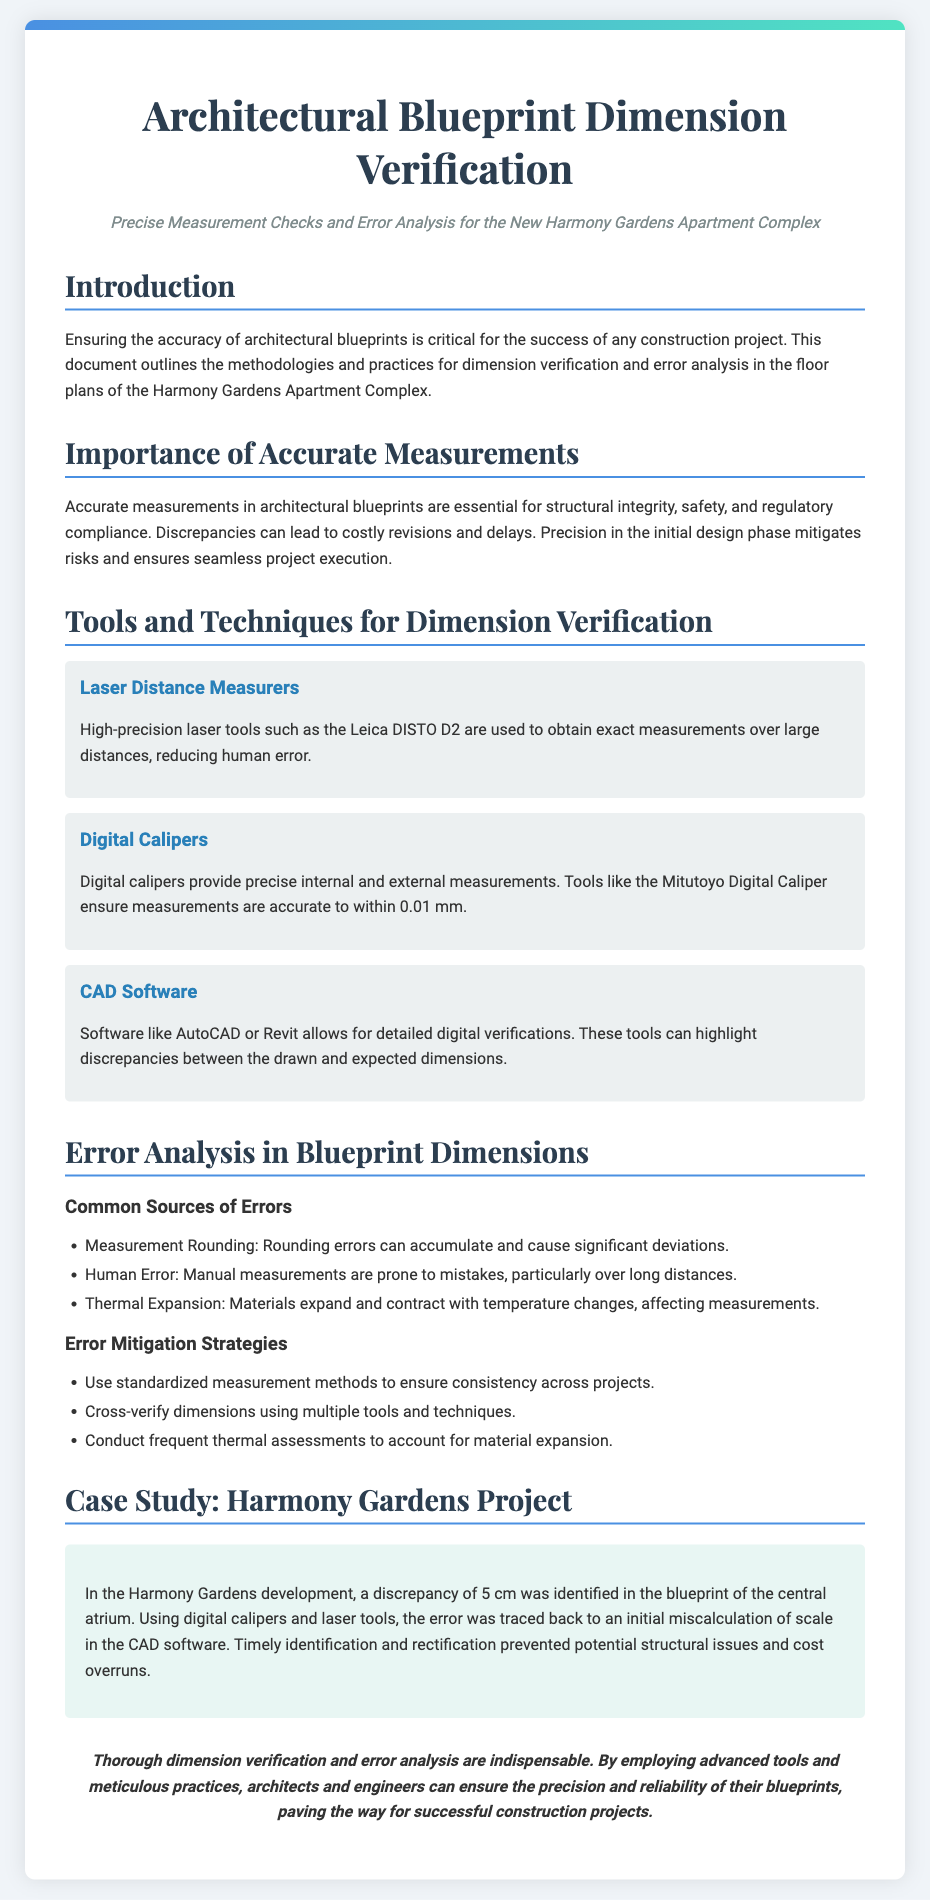What is the title of the document? The title is stated at the top of the document and is "Architectural Blueprint Dimension Verification."
Answer: Architectural Blueprint Dimension Verification What is the subtitle of the document? The subtitle provides additional context and is "Precise Measurement Checks and Error Analysis for the New Harmony Gardens Apartment Complex."
Answer: Precise Measurement Checks and Error Analysis for the New Harmony Gardens Apartment Complex What is one tool used for dimension verification? The document lists multiple tools and one of them is "Laser Distance Measurers."
Answer: Laser Distance Measurers What was the identified discrepancy in the Harmony Gardens project? The document refers to a specific discrepancy of 5 cm in the central atrium blueprint, which was resolved during verification.
Answer: 5 cm What are two common sources of errors mentioned? The document lists various sources of errors, so one can refer to both "Measurement Rounding" and "Human Error" as part of the content.
Answer: Measurement Rounding, Human Error How does thermal expansion affect measurements? The document explains that thermal expansion involves materials altering dimensions due to temperature changes, hence influencing accuracy.
Answer: It affects measurements What is the conclusion provided in the document? The conclusion summarizes the importance of accurate measurements and is, "Thorough dimension verification and error analysis are indispensable."
Answer: Thorough dimension verification and error analysis are indispensable What type of case study is presented? The document includes a specific example related to a project and is labeled as "Case Study: Harmony Gardens Project."
Answer: Case Study: Harmony Gardens Project What software is mentioned for digital verifications? The document lists software used for verification, including "AutoCAD."
Answer: AutoCAD 